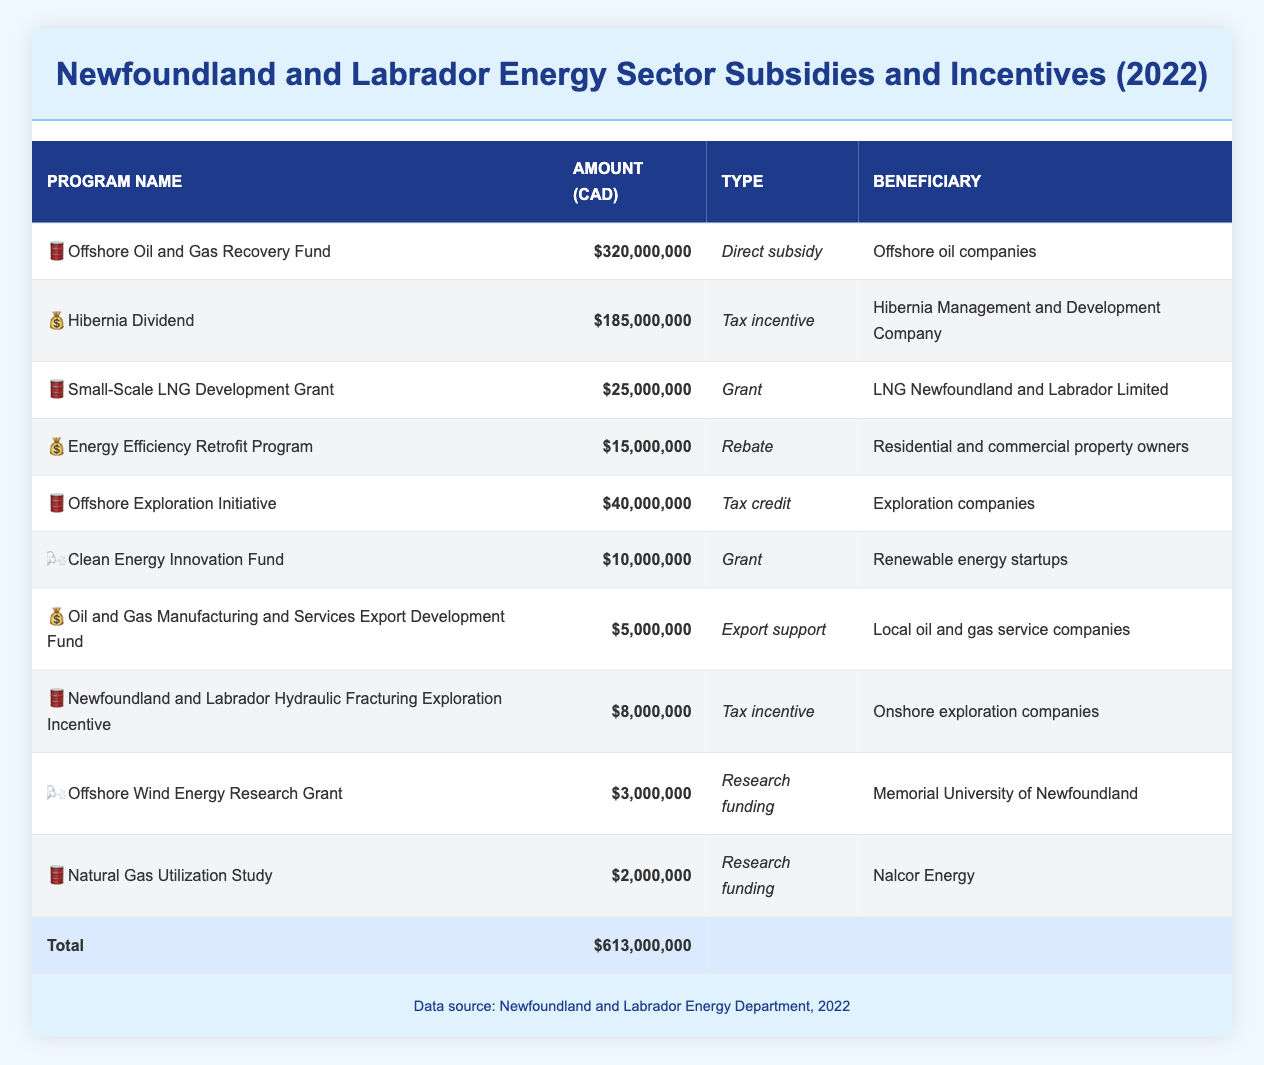What is the total amount of subsidies and incentives in Newfoundland and Labrador for 2022? To find the total, we look at the last row of the table which summarizes the data. The total amount listed for 2022 is 613,000,000 CAD.
Answer: 613,000,000 CAD Which beneficiary received the highest subsidy? By reviewing the 'Amount' column, the largest value is for the 'Offshore Oil and Gas Recovery Fund', which amounts to 320,000,000 CAD. The beneficiary for this fund is 'Offshore oil companies'.
Answer: Offshore oil companies How many grants are listed in the table? We need to count the rows where 'Type' equals 'Grant'. There are two grants: 'Small-Scale LNG Development Grant' and 'Clean Energy Innovation Fund'. Therefore, the count is 2.
Answer: 2 What is the difference in funding between the 'Hibernia Dividend' and the 'Energy Efficiency Retrofit Program'? To find the difference, we subtract the amount for the 'Energy Efficiency Retrofit Program' (15,000,000 CAD) from the 'Hibernia Dividend' (185,000,000 CAD). The calculation is 185,000,000 - 15,000,000 = 170,000,000 CAD.
Answer: 170,000,000 CAD Is there a research funding program listed that supports renewable energy startups? Checking the table, we see the 'Clean Energy Innovation Fund' is defined as a grant and supports renewable energy startups, which means the statement is true.
Answer: Yes What percentage of total subsidies does the 'Offshore Wind Energy Research Grant' represent? First, identify the amount for the 'Offshore Wind Energy Research Grant', which is 3,000,000 CAD. Next, calculate the percentage of total subsidies (613,000,000 CAD) represented by this grant: (3,000,000 / 613,000,000) * 100 = 0.49%.
Answer: 0.49% Are all beneficiaries related to oil and gas in some way? Reviewing the list of beneficiaries, we can see that some, such as 'Memorial University of Newfoundland' and 'Nalcor Energy', are involved in research and utilities and do not directly relate to oil and gas operations. Therefore, the statement is false.
Answer: No Which type of funding has the least amount allocated? Looking through the table, 'Natural Gas Utilization Study' is listed under 'Research funding' and has the least amount allocated at 2,000,000 CAD.
Answer: 2,000,000 CAD What is the average amount received by the tax incentive programs? Identifying the tax incentive programs, we have two: 'Hibernia Dividend' (185,000,000 CAD) and 'Newfoundland and Labrador Hydraulic Fracturing Exploration Incentive' (8,000,000 CAD). The average is calculated as (185,000,000 + 8,000,000) / 2 = 96,500,000 CAD.
Answer: 96,500,000 CAD 